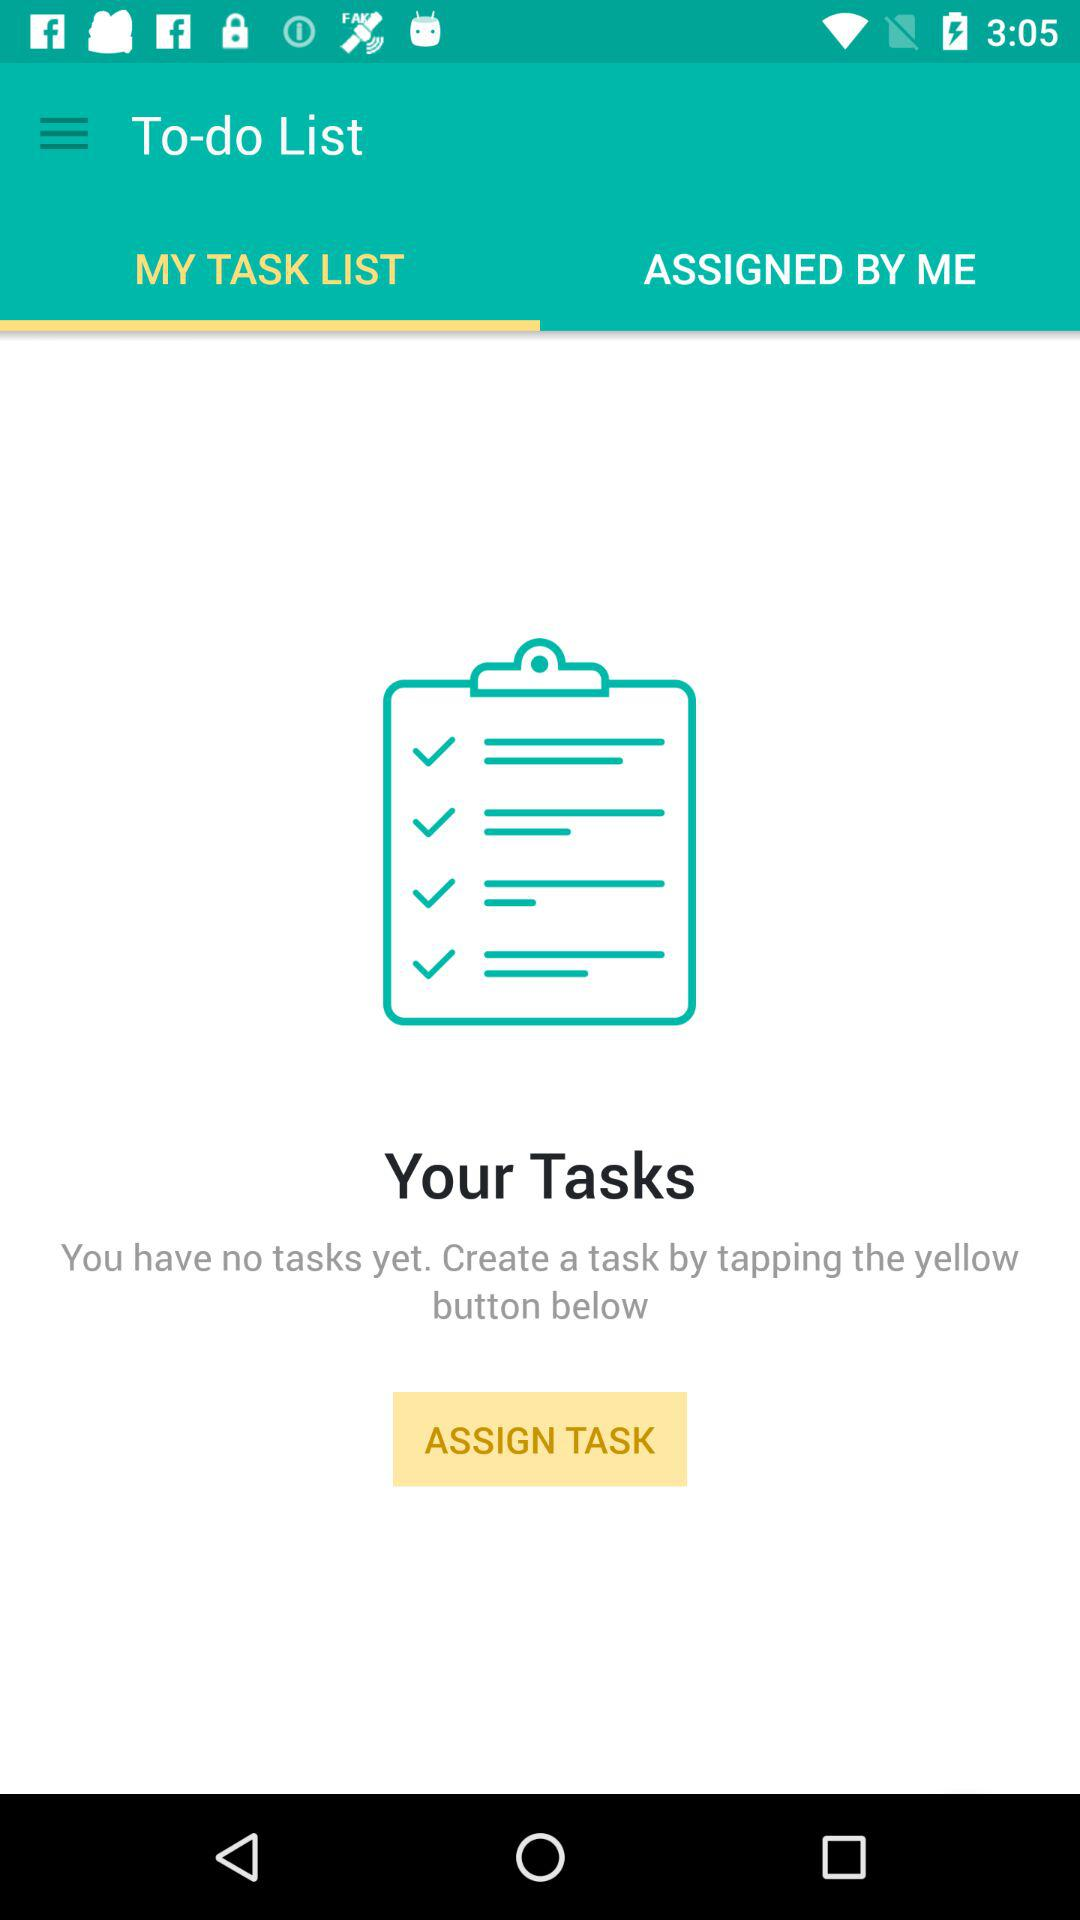Which tab is selected? MY TASK LIST is selected. 